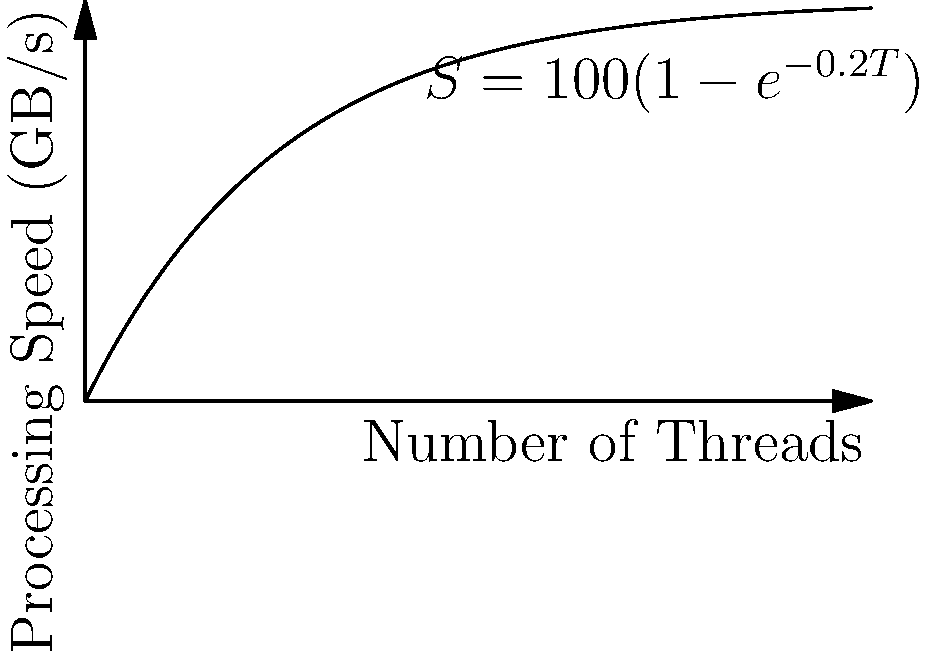Given the graph showing the relationship between the number of threads (T) and data processing speed (S) in GB/s, described by the equation $S = 100(1-e^{-0.2T})$, at what number of threads is the rate of increase in processing speed exactly half of its initial rate? To solve this problem, we need to follow these steps:

1) First, let's find the initial rate of increase. This is the derivative of S with respect to T at T = 0.

   $\frac{dS}{dT} = 100 \cdot 0.2e^{-0.2T}$

   At T = 0, $\frac{dS}{dT} = 20$ GB/s per thread

2) We want to find when this rate is exactly half of the initial rate, i.e., 10 GB/s per thread.

   $100 \cdot 0.2e^{-0.2T} = 10$

3) Solve this equation:

   $e^{-0.2T} = 0.5$
   $-0.2T = \ln(0.5)$
   $T = -\frac{\ln(0.5)}{0.2} = \frac{\ln(2)}{0.2}$

4) Calculate the result:

   $T = \frac{0.693147}{0.2} \approx 3.47$ threads

Therefore, the rate of increase in processing speed is exactly half of its initial rate when T ≈ 3.47 threads.
Answer: 3.47 threads 